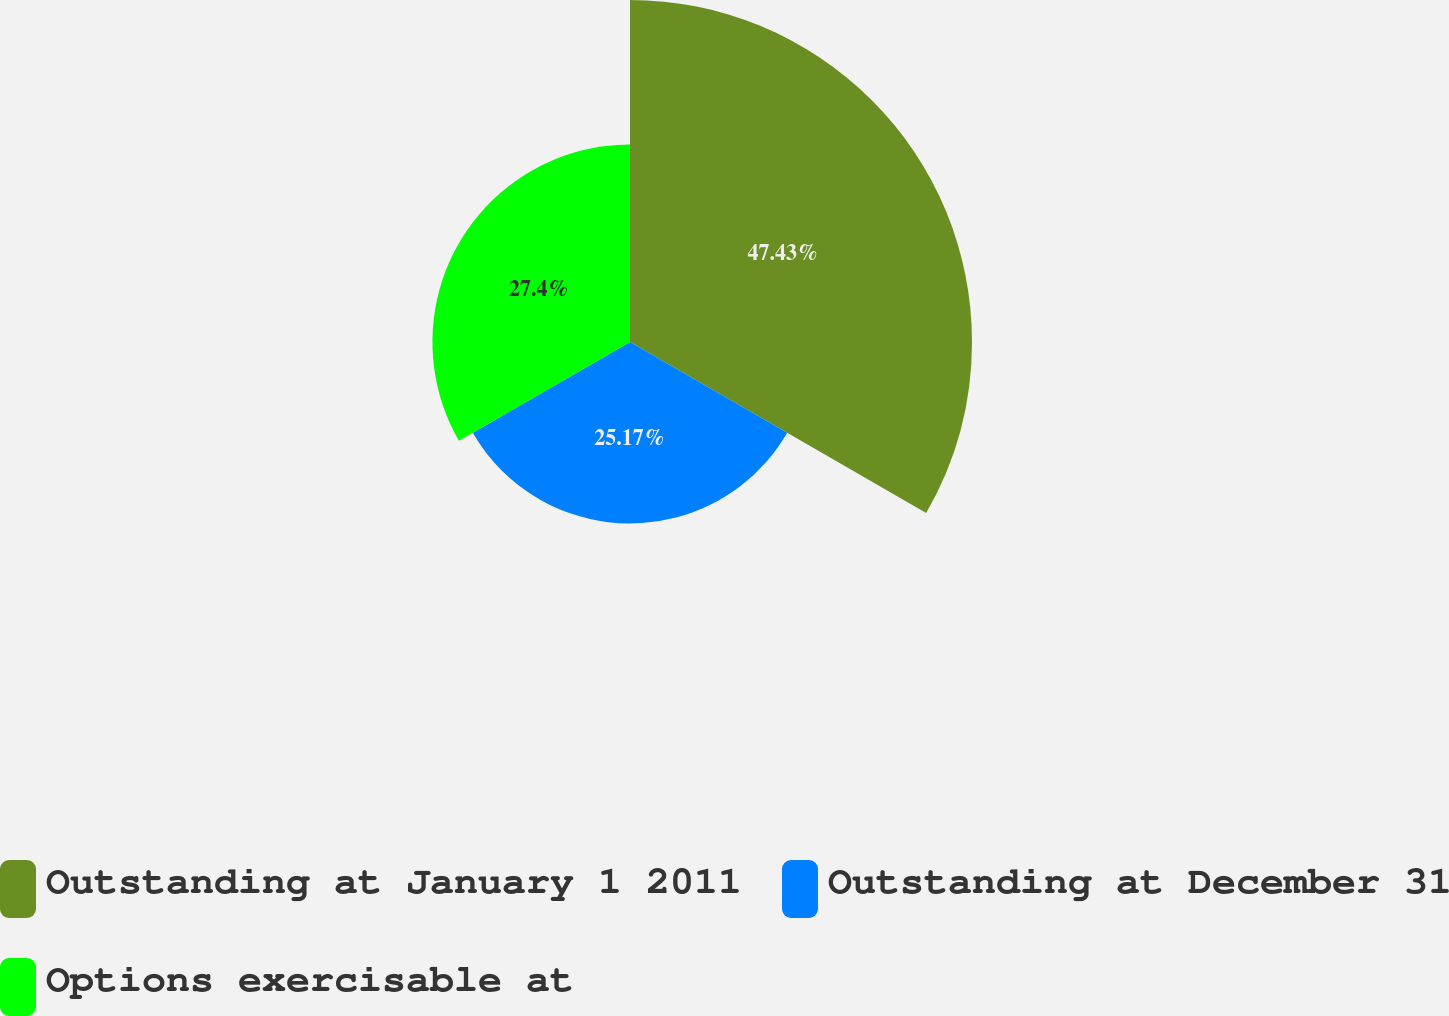<chart> <loc_0><loc_0><loc_500><loc_500><pie_chart><fcel>Outstanding at January 1 2011<fcel>Outstanding at December 31<fcel>Options exercisable at<nl><fcel>47.43%<fcel>25.17%<fcel>27.4%<nl></chart> 